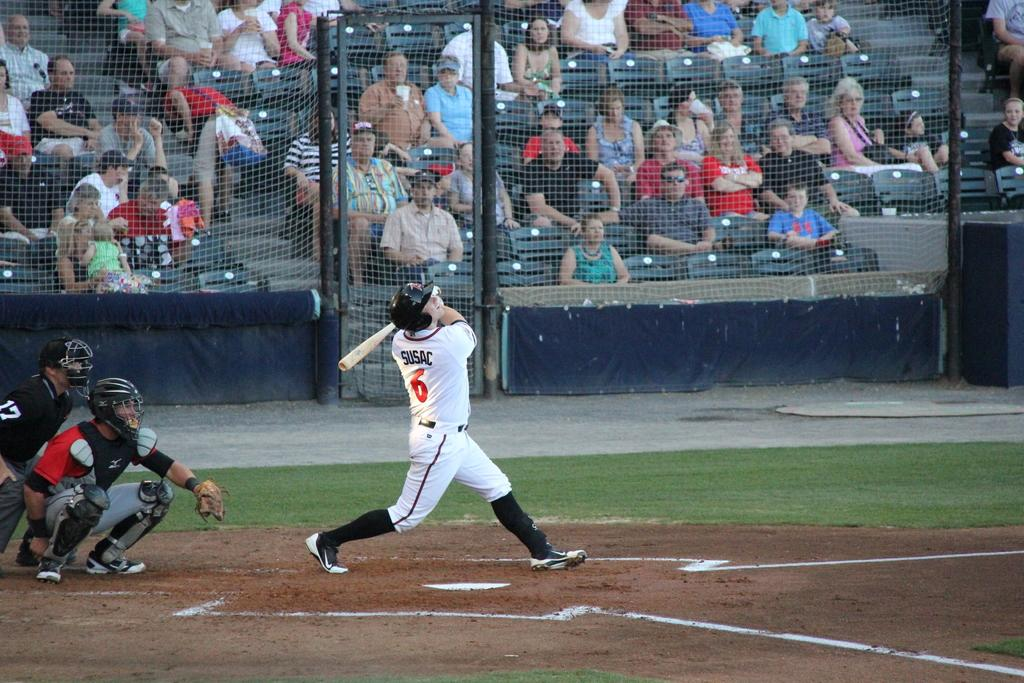Provide a one-sentence caption for the provided image. Baseball player Susac at the batting plate hitting the baseball. 